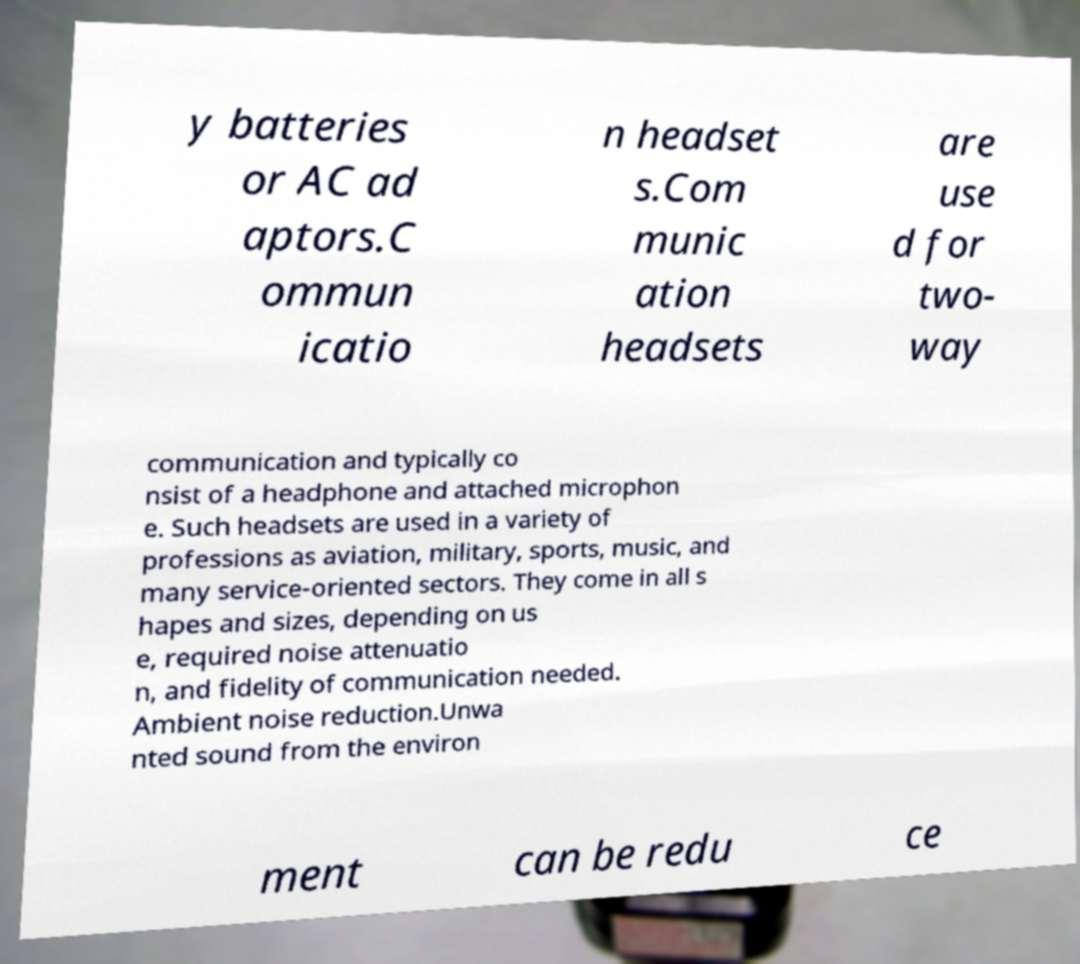There's text embedded in this image that I need extracted. Can you transcribe it verbatim? y batteries or AC ad aptors.C ommun icatio n headset s.Com munic ation headsets are use d for two- way communication and typically co nsist of a headphone and attached microphon e. Such headsets are used in a variety of professions as aviation, military, sports, music, and many service-oriented sectors. They come in all s hapes and sizes, depending on us e, required noise attenuatio n, and fidelity of communication needed. Ambient noise reduction.Unwa nted sound from the environ ment can be redu ce 